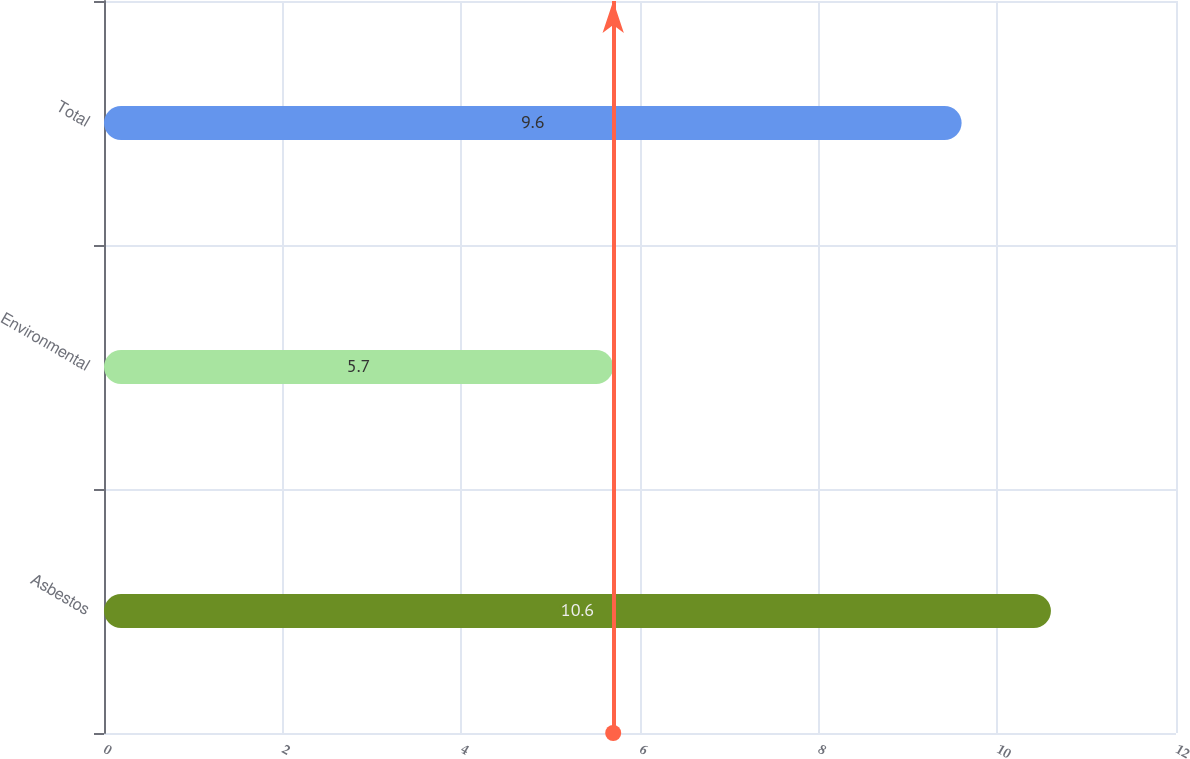<chart> <loc_0><loc_0><loc_500><loc_500><bar_chart><fcel>Asbestos<fcel>Environmental<fcel>Total<nl><fcel>10.6<fcel>5.7<fcel>9.6<nl></chart> 